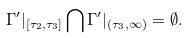<formula> <loc_0><loc_0><loc_500><loc_500>\Gamma ^ { \prime } | _ { [ \tau _ { 2 } , \tau _ { 3 } ] } \bigcap \Gamma ^ { \prime } | _ { ( \tau _ { 3 } , \infty ) } = \emptyset .</formula> 